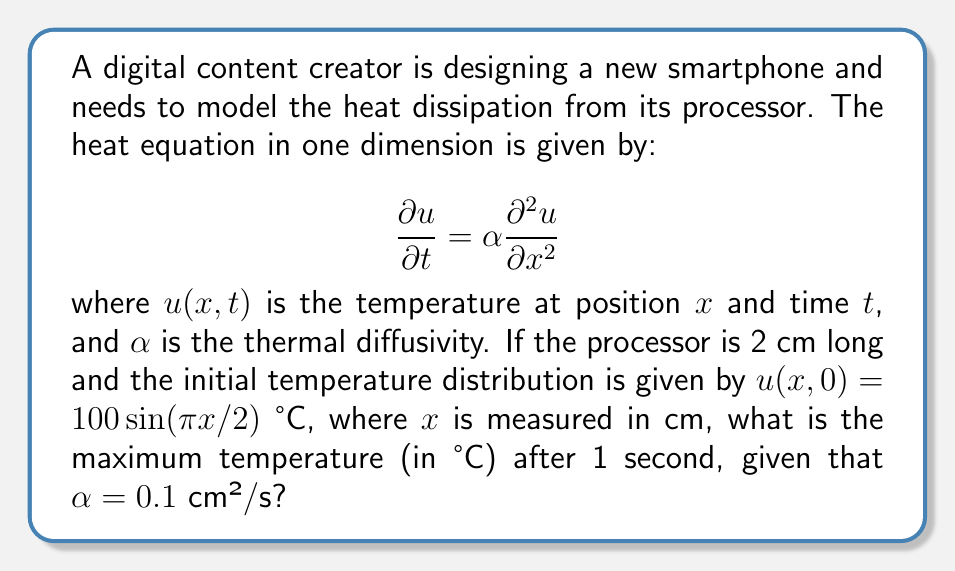Can you answer this question? Let's approach this step-by-step:

1) The general solution to the 1D heat equation with the given initial condition is:

   $$u(x,t) = \sum_{n=1}^{\infty} B_n \sin(\frac{n\pi x}{L}) e^{-\alpha(\frac{n\pi}{L})^2t}$$

   where $L$ is the length of the processor (2 cm in this case).

2) Our initial condition matches the first term of this series with $n=1$, so we only need to consider:

   $$u(x,t) = 100 \sin(\frac{\pi x}{2}) e^{-\alpha(\frac{\pi}{2})^2t}$$

3) To find the maximum temperature after 1 second, we need to evaluate this at $t=1$:

   $$u(x,1) = 100 \sin(\frac{\pi x}{2}) e^{-0.1(\frac{\pi}{2})^2}$$

4) The $\sin(\frac{\pi x}{2})$ term reaches its maximum value of 1 when $x=1$ cm (half the length of the processor).

5) Let's calculate the exponential term:

   $$e^{-0.1(\frac{\pi}{2})^2} \approx e^{-0.1 * 2.467} \approx e^{-0.2467} \approx 0.7814$$

6) Therefore, the maximum temperature after 1 second is:

   $$u_{max} = 100 * 1 * 0.7814 = 78.14 \text{ °C}$$
Answer: 78.14 °C 